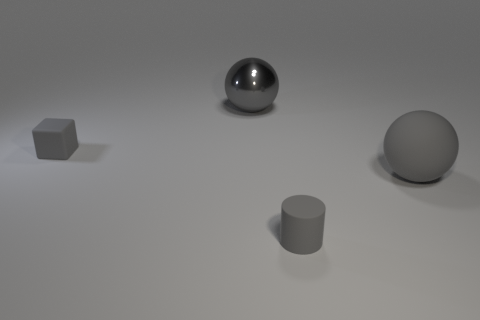Is there any other thing that is made of the same material as the tiny gray block?
Your answer should be compact. Yes. There is a rubber thing that is the same shape as the gray metal thing; what is its size?
Your answer should be very brief. Large. Are there fewer big gray metal things behind the block than tiny matte things on the right side of the large gray matte ball?
Ensure brevity in your answer.  No. There is a gray matte object that is both right of the gray shiny ball and on the left side of the large rubber object; what shape is it?
Make the answer very short. Cylinder. What size is the gray block that is the same material as the gray cylinder?
Offer a terse response. Small. There is a shiny object; is it the same color as the rubber object that is on the right side of the gray cylinder?
Make the answer very short. Yes. What is the gray object that is behind the big gray rubber sphere and in front of the large gray shiny thing made of?
Provide a succinct answer. Rubber. What size is the metallic ball that is the same color as the tiny matte cube?
Provide a succinct answer. Large. There is a thing right of the gray rubber cylinder; does it have the same shape as the matte object behind the big gray matte sphere?
Your answer should be compact. No. Are there any small cubes?
Keep it short and to the point. Yes. 